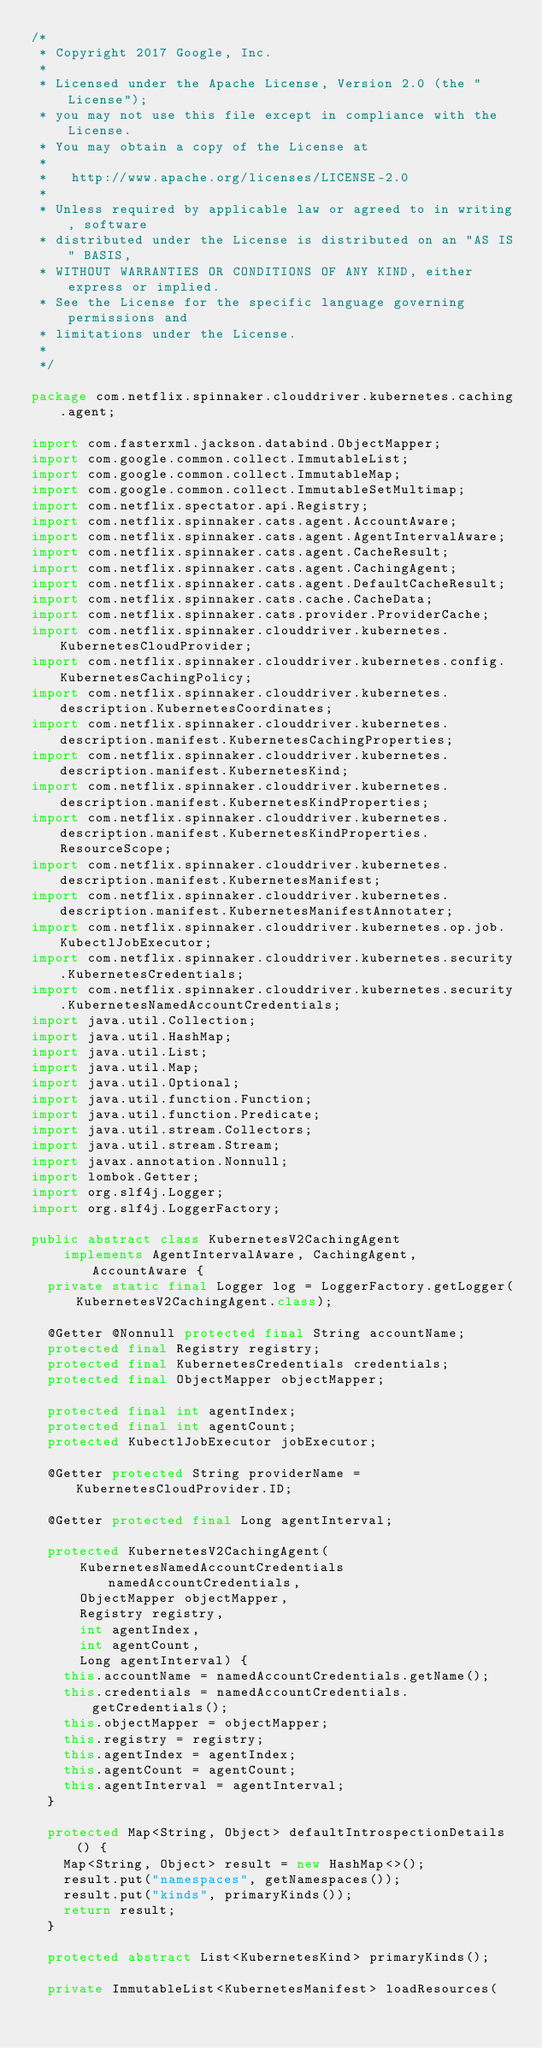<code> <loc_0><loc_0><loc_500><loc_500><_Java_>/*
 * Copyright 2017 Google, Inc.
 *
 * Licensed under the Apache License, Version 2.0 (the "License");
 * you may not use this file except in compliance with the License.
 * You may obtain a copy of the License at
 *
 *   http://www.apache.org/licenses/LICENSE-2.0
 *
 * Unless required by applicable law or agreed to in writing, software
 * distributed under the License is distributed on an "AS IS" BASIS,
 * WITHOUT WARRANTIES OR CONDITIONS OF ANY KIND, either express or implied.
 * See the License for the specific language governing permissions and
 * limitations under the License.
 *
 */

package com.netflix.spinnaker.clouddriver.kubernetes.caching.agent;

import com.fasterxml.jackson.databind.ObjectMapper;
import com.google.common.collect.ImmutableList;
import com.google.common.collect.ImmutableMap;
import com.google.common.collect.ImmutableSetMultimap;
import com.netflix.spectator.api.Registry;
import com.netflix.spinnaker.cats.agent.AccountAware;
import com.netflix.spinnaker.cats.agent.AgentIntervalAware;
import com.netflix.spinnaker.cats.agent.CacheResult;
import com.netflix.spinnaker.cats.agent.CachingAgent;
import com.netflix.spinnaker.cats.agent.DefaultCacheResult;
import com.netflix.spinnaker.cats.cache.CacheData;
import com.netflix.spinnaker.cats.provider.ProviderCache;
import com.netflix.spinnaker.clouddriver.kubernetes.KubernetesCloudProvider;
import com.netflix.spinnaker.clouddriver.kubernetes.config.KubernetesCachingPolicy;
import com.netflix.spinnaker.clouddriver.kubernetes.description.KubernetesCoordinates;
import com.netflix.spinnaker.clouddriver.kubernetes.description.manifest.KubernetesCachingProperties;
import com.netflix.spinnaker.clouddriver.kubernetes.description.manifest.KubernetesKind;
import com.netflix.spinnaker.clouddriver.kubernetes.description.manifest.KubernetesKindProperties;
import com.netflix.spinnaker.clouddriver.kubernetes.description.manifest.KubernetesKindProperties.ResourceScope;
import com.netflix.spinnaker.clouddriver.kubernetes.description.manifest.KubernetesManifest;
import com.netflix.spinnaker.clouddriver.kubernetes.description.manifest.KubernetesManifestAnnotater;
import com.netflix.spinnaker.clouddriver.kubernetes.op.job.KubectlJobExecutor;
import com.netflix.spinnaker.clouddriver.kubernetes.security.KubernetesCredentials;
import com.netflix.spinnaker.clouddriver.kubernetes.security.KubernetesNamedAccountCredentials;
import java.util.Collection;
import java.util.HashMap;
import java.util.List;
import java.util.Map;
import java.util.Optional;
import java.util.function.Function;
import java.util.function.Predicate;
import java.util.stream.Collectors;
import java.util.stream.Stream;
import javax.annotation.Nonnull;
import lombok.Getter;
import org.slf4j.Logger;
import org.slf4j.LoggerFactory;

public abstract class KubernetesV2CachingAgent
    implements AgentIntervalAware, CachingAgent, AccountAware {
  private static final Logger log = LoggerFactory.getLogger(KubernetesV2CachingAgent.class);

  @Getter @Nonnull protected final String accountName;
  protected final Registry registry;
  protected final KubernetesCredentials credentials;
  protected final ObjectMapper objectMapper;

  protected final int agentIndex;
  protected final int agentCount;
  protected KubectlJobExecutor jobExecutor;

  @Getter protected String providerName = KubernetesCloudProvider.ID;

  @Getter protected final Long agentInterval;

  protected KubernetesV2CachingAgent(
      KubernetesNamedAccountCredentials namedAccountCredentials,
      ObjectMapper objectMapper,
      Registry registry,
      int agentIndex,
      int agentCount,
      Long agentInterval) {
    this.accountName = namedAccountCredentials.getName();
    this.credentials = namedAccountCredentials.getCredentials();
    this.objectMapper = objectMapper;
    this.registry = registry;
    this.agentIndex = agentIndex;
    this.agentCount = agentCount;
    this.agentInterval = agentInterval;
  }

  protected Map<String, Object> defaultIntrospectionDetails() {
    Map<String, Object> result = new HashMap<>();
    result.put("namespaces", getNamespaces());
    result.put("kinds", primaryKinds());
    return result;
  }

  protected abstract List<KubernetesKind> primaryKinds();

  private ImmutableList<KubernetesManifest> loadResources(</code> 